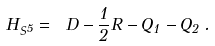<formula> <loc_0><loc_0><loc_500><loc_500>H _ { S ^ { 5 } } = \ D - \frac { 1 } { 2 } R - Q _ { 1 } - Q _ { 2 } \, .</formula> 